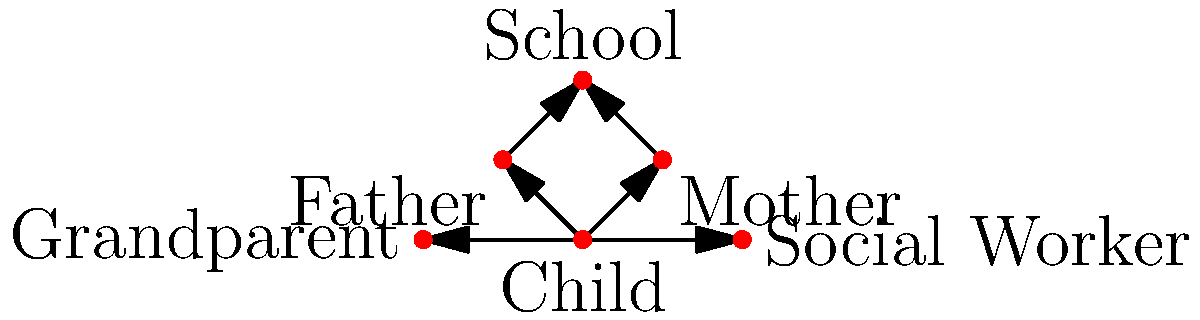In the social network analysis graph for a child welfare case, which node has the highest out-degree centrality, and what does this imply about the child's support system? To answer this question, we need to follow these steps:

1. Understand out-degree centrality:
   Out-degree centrality is the number of outgoing connections a node has in a directed graph.

2. Analyze the graph:
   - Child node: 4 outgoing connections (to Mother, Father, Grandparent, and Social Worker)
   - Mother node: 1 outgoing connection (to School)
   - Father node: 1 outgoing connection (to School)
   - School node: 0 outgoing connections
   - Grandparent node: 0 outgoing connections
   - Social Worker node: 0 outgoing connections

3. Identify the node with the highest out-degree centrality:
   The Child node has the highest out-degree centrality with 4 outgoing connections.

4. Interpret the implications:
   - The child has direct connections to multiple support figures.
   - This suggests a diverse support system involving family members and professionals.
   - The child is at the center of the support network, indicating that various stakeholders are directly involved in the child's welfare.
   - The high out-degree centrality of the child node implies that information about the child's situation can be directly communicated to multiple parties, potentially leading to better coordination in the child welfare case.

5. Consider the professional context:
   As a social worker, this network structure suggests that the child has multiple points of contact for support, which can be beneficial for their overall well-being and for gathering comprehensive information about the child's situation.
Answer: The Child node; indicates a diverse, directly accessible support system. 